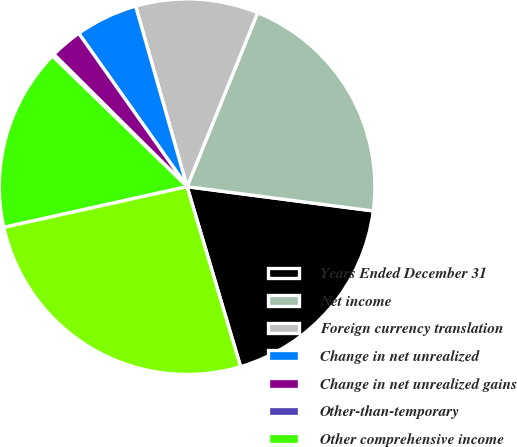<chart> <loc_0><loc_0><loc_500><loc_500><pie_chart><fcel>Years Ended December 31<fcel>Net income<fcel>Foreign currency translation<fcel>Change in net unrealized<fcel>Change in net unrealized gains<fcel>Other-than-temporary<fcel>Other comprehensive income<fcel>Total comprehensive income<nl><fcel>18.34%<fcel>20.93%<fcel>10.55%<fcel>5.37%<fcel>2.77%<fcel>0.18%<fcel>15.74%<fcel>26.12%<nl></chart> 